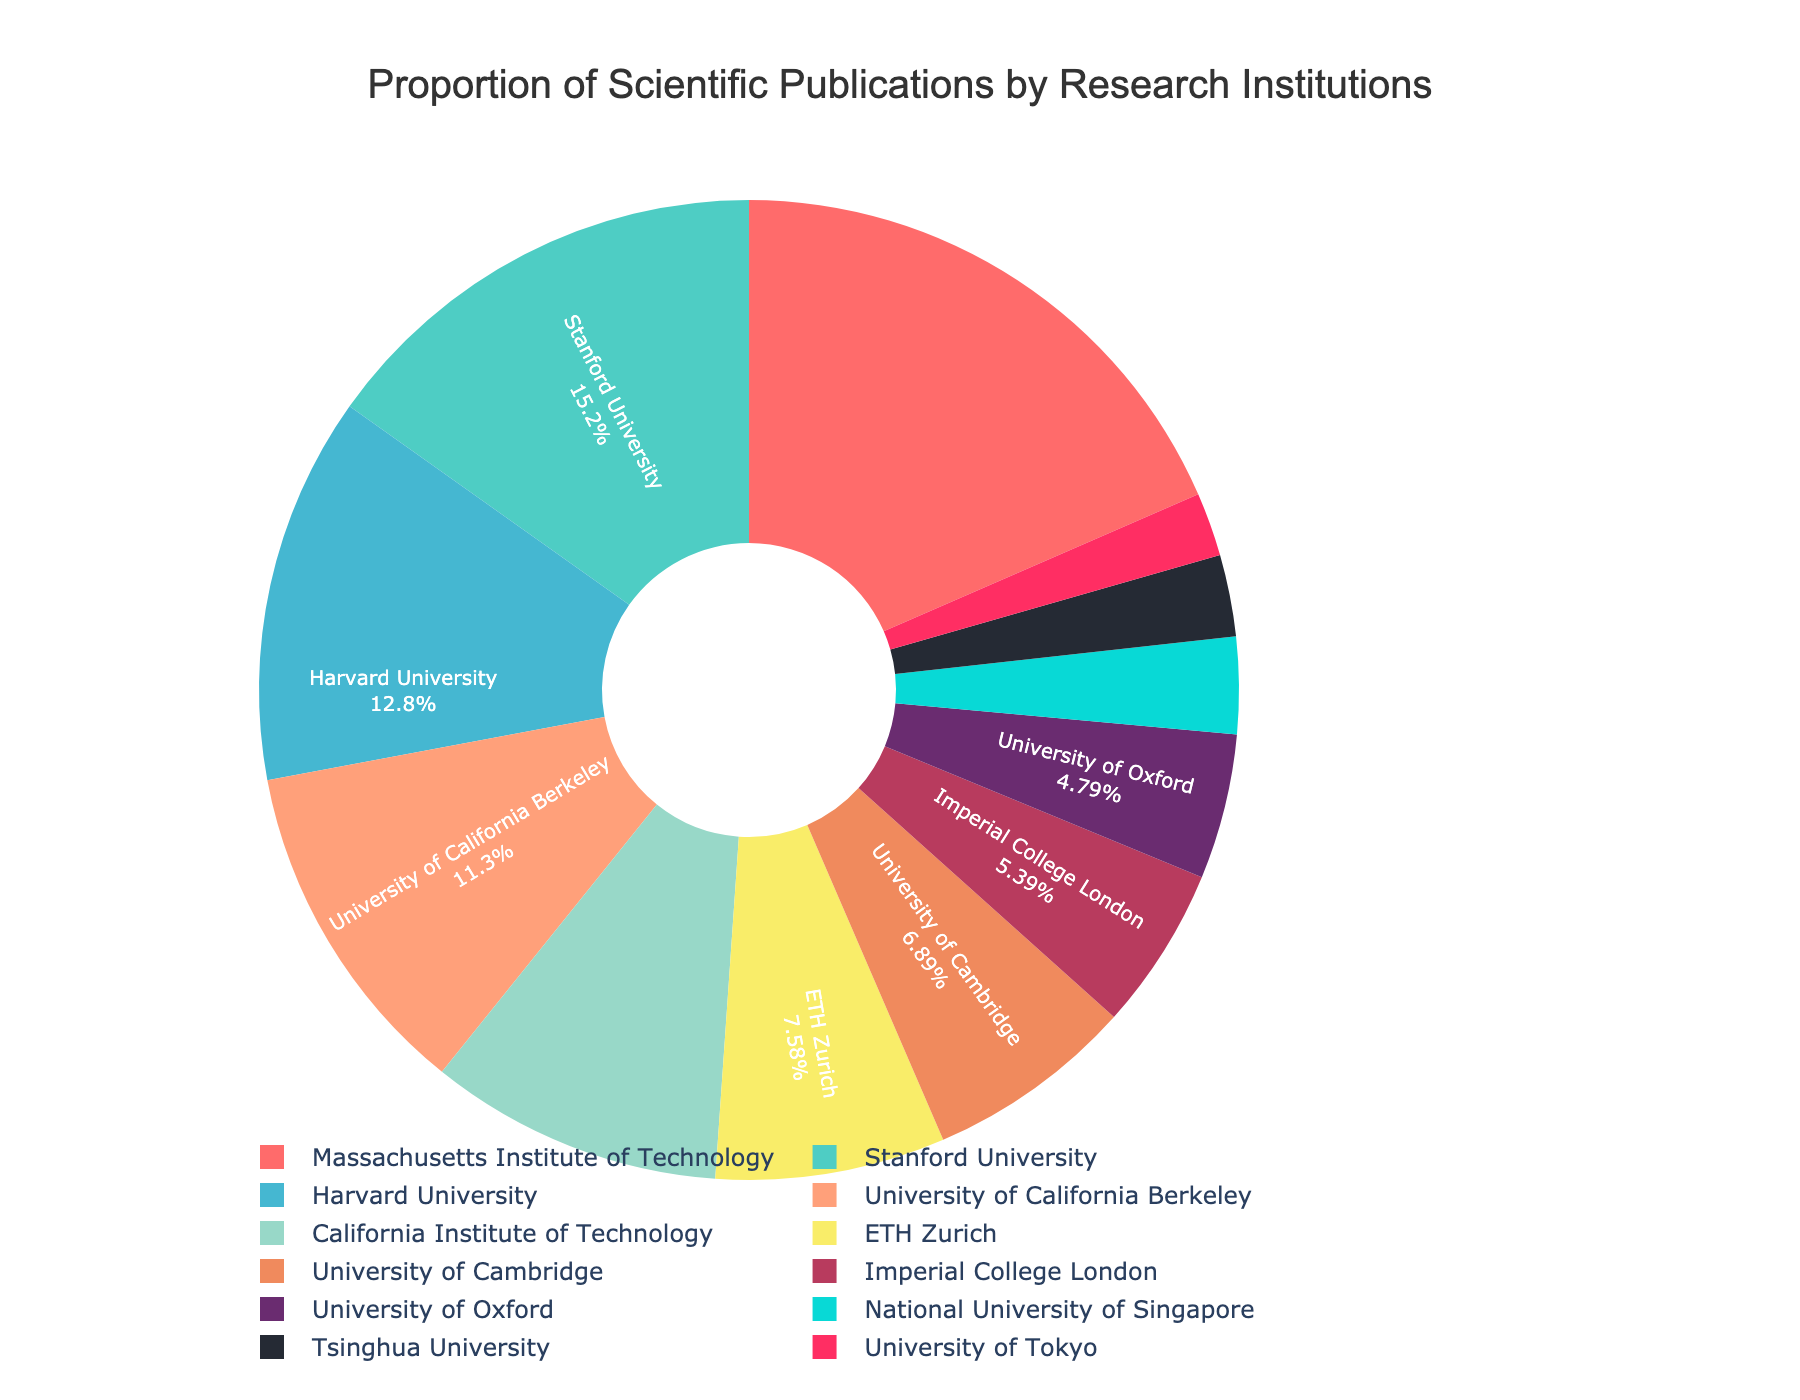What percentage of scientific publications is produced by the Massachusetts Institute of Technology? Refer to the figure and locate the section labeled "Massachusetts Institute of Technology" to see its percentage.
Answer: 18.5% Which institution has a higher percentage of publications, Harvard University or University of California Berkeley? Compare the percentages for Harvard University (12.8%) and University of California Berkeley (11.3%) to determine which is higher.
Answer: Harvard University What is the combined percentage of publications produced by Stanford University and California Institute of Technology? Add the percentages for Stanford University (15.2%) and California Institute of Technology (9.7%). The combined percentage is 15.2% + 9.7%.
Answer: 24.9% Identify the institution represented by the red color in the pie chart. Examine the section of the pie chart colored red and refer to the legend to identify the corresponding institution.
Answer: Massachusetts Institute of Technology What is the difference in publication percentage between ETH Zurich and University of Cambridge? Subtract the percentage for University of Cambridge (6.9%) from the percentage for ETH Zurich (7.6%). The difference is 7.6% - 6.9%.
Answer: 0.7% Which institution has the smallest proportion of publications? Locate the section with the smallest percentage in the pie chart, and refer to the label to identify the institution.
Answer: University of Tokyo Is the percentage of publications by Imperial College London greater than that by University of Oxford? Compare the percentages for Imperial College London (5.4%) and University of Oxford (4.8%) to see if the former is greater.
Answer: Yes What is the average percentage of publications for the top three institutions? Identify the top three institutions (Massachusetts Institute of Technology 18.5%, Stanford University 15.2%, Harvard University 12.8%) and calculate the average: (18.5% + 15.2% + 12.8%) / 3.
Answer: 15.5% Which institution has a lower percentage of publications, Tsinghua University or National University of Singapore? Compare the percentages for Tsinghua University (2.7%) and National University of Singapore (3.2%) to see which is lower.
Answer: Tsinghua University 